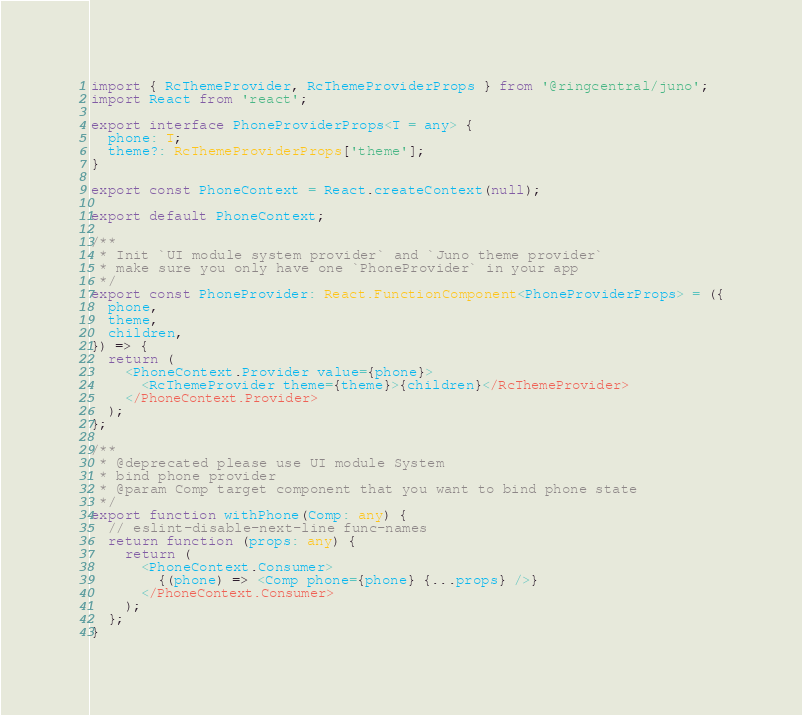Convert code to text. <code><loc_0><loc_0><loc_500><loc_500><_TypeScript_>import { RcThemeProvider, RcThemeProviderProps } from '@ringcentral/juno';
import React from 'react';

export interface PhoneProviderProps<T = any> {
  phone: T;
  theme?: RcThemeProviderProps['theme'];
}

export const PhoneContext = React.createContext(null);

export default PhoneContext;

/**
 * Init `UI module system provider` and `Juno theme provider`
 * make sure you only have one `PhoneProvider` in your app
 */
export const PhoneProvider: React.FunctionComponent<PhoneProviderProps> = ({
  phone,
  theme,
  children,
}) => {
  return (
    <PhoneContext.Provider value={phone}>
      <RcThemeProvider theme={theme}>{children}</RcThemeProvider>
    </PhoneContext.Provider>
  );
};

/**
 * @deprecated please use UI module System
 * bind phone provider
 * @param Comp target component that you want to bind phone state
 */
export function withPhone(Comp: any) {
  // eslint-disable-next-line func-names
  return function (props: any) {
    return (
      <PhoneContext.Consumer>
        {(phone) => <Comp phone={phone} {...props} />}
      </PhoneContext.Consumer>
    );
  };
}
</code> 